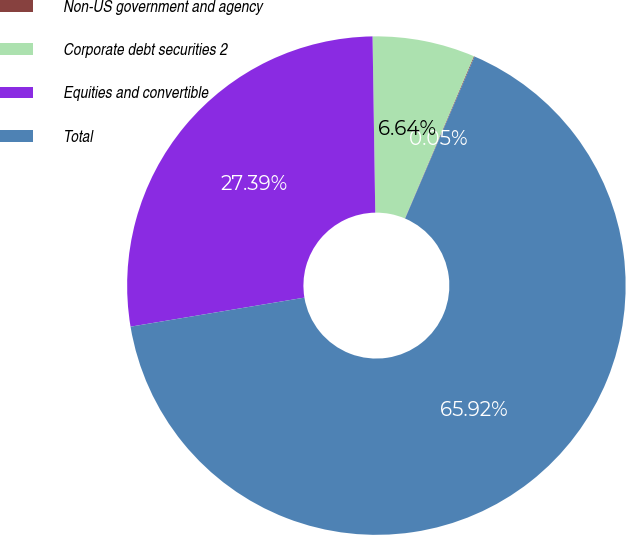Convert chart. <chart><loc_0><loc_0><loc_500><loc_500><pie_chart><fcel>Non-US government and agency<fcel>Corporate debt securities 2<fcel>Equities and convertible<fcel>Total<nl><fcel>0.05%<fcel>6.64%<fcel>27.39%<fcel>65.92%<nl></chart> 